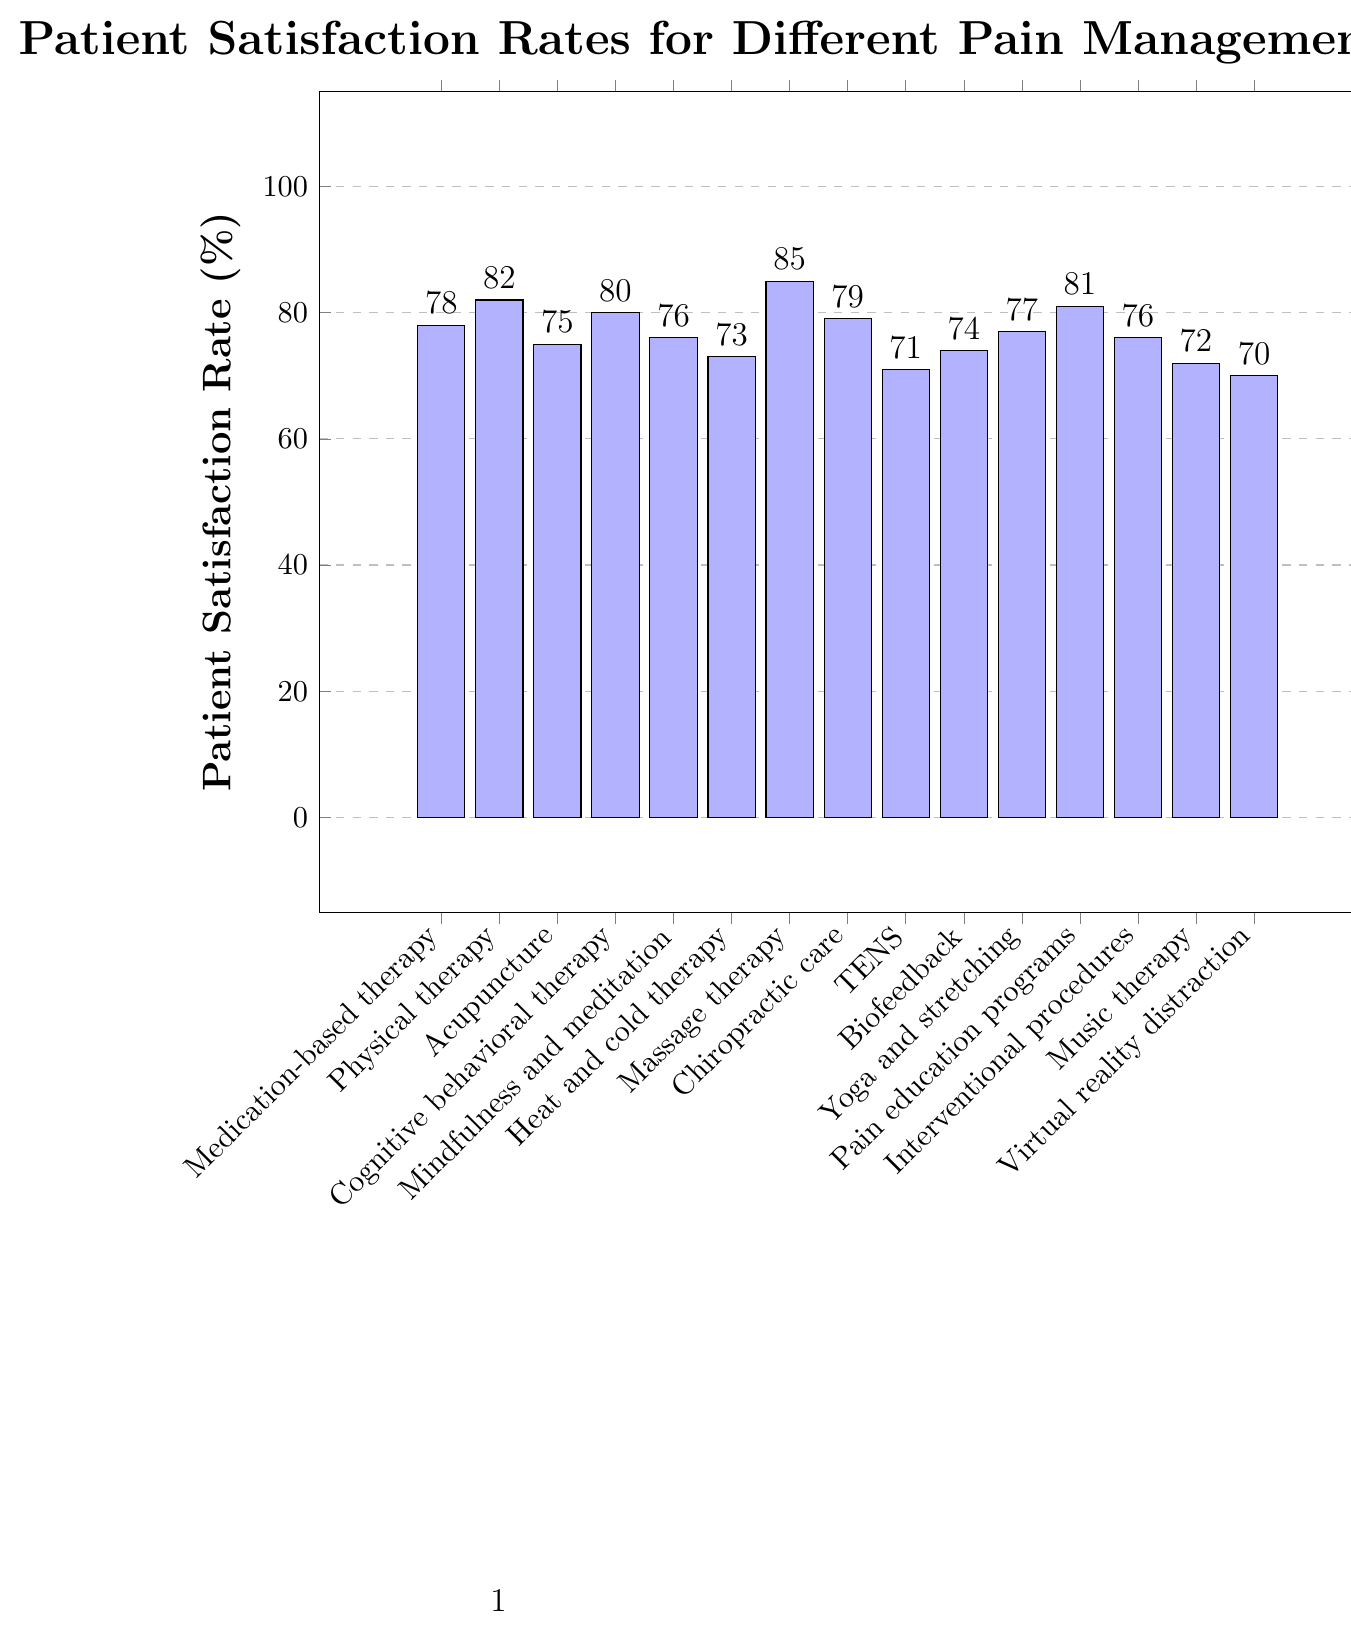Which pain management approach has the highest patient satisfaction rate? Look at the bar chart and find the tallest bar, which represents the highest patient satisfaction rate.
Answer: Massage therapy What's the difference in patient satisfaction rates between acupuncture and cognitive behavioral therapy? Check the bar heights for acupuncture and cognitive behavioral therapy. Acupuncture has a satisfaction rate of 75%, and cognitive behavioral therapy has 80%. Subtract to find the difference: 80% - 75% = 5%.
Answer: 5% Are there any pain management approaches with the same patient satisfaction rates? Examine the chart and look for bars with the same height. Both mindfulness and meditation and interventional procedures have a satisfaction rate of 76%.
Answer: Yes, mindfulness and meditation, and interventional procedures both have 76% What's the average patient satisfaction rate of the top three pain management approaches? Identify the top three highest bars which are massage therapy (85%), physical therapy (82%), and pain education programs (81%). Calculate the average: (85 + 82 + 81) / 3 = 82.67%.
Answer: 82.67% Which pain management approach has the least patient satisfaction rate, and what is it? Find the shortest bar on the chart, which indicates the lowest patient satisfaction rate.
Answer: Virtual reality distraction, 70% How many pain management approaches have a patient satisfaction rate of 80% or higher? Count the bars that meet or exceed 80%. They are physical therapy (82%), cognitive behavioral therapy (80%), massage therapy (85%), pain education programs (81%), and chiropractic care (79%). Since chiropractic is 79%, we exclude it, leaving us with four bars.
Answer: 4 What is the range of patient satisfaction rates in the chart? Identify the highest and lowest patient satisfaction rates: highest is massage therapy (85%) and lowest is virtual reality distraction (70%). Subtract the lowest rate from the highest: 85% - 70% = 15%.
Answer: 15% Which pain management approaches fall below a 75% satisfaction rate? Identify bars that represent satisfaction rates below 75%. The approaches are TENS (71%), heat and cold therapy (73%), music therapy (72%), virtual reality distraction (70%), and biofeedback (74%).
Answer: TENS, heat and cold therapy, music therapy, virtual reality distraction, biofeedback 